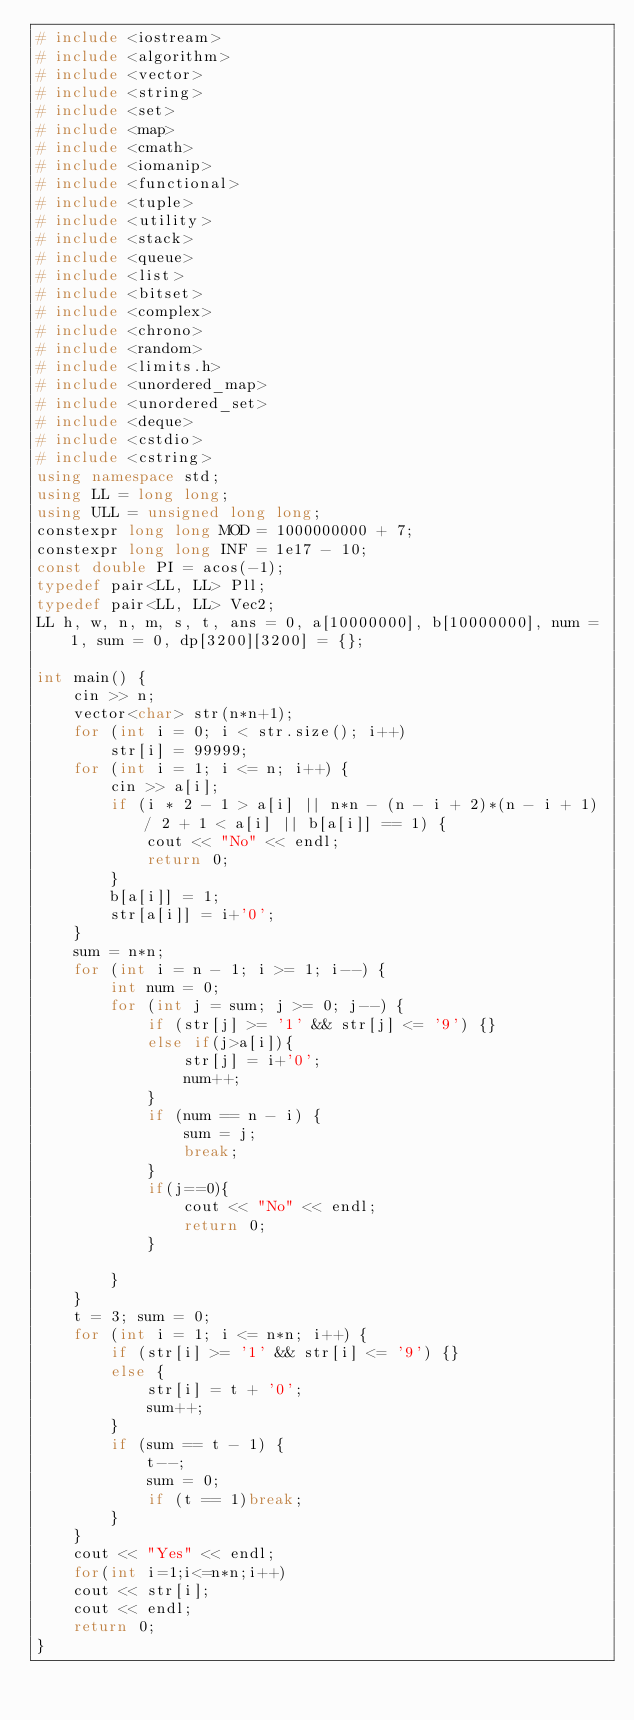<code> <loc_0><loc_0><loc_500><loc_500><_C++_># include <iostream>
# include <algorithm>
# include <vector>
# include <string>
# include <set>
# include <map>
# include <cmath>
# include <iomanip>
# include <functional>
# include <tuple>
# include <utility>
# include <stack>
# include <queue>
# include <list>
# include <bitset>
# include <complex>
# include <chrono>
# include <random>
# include <limits.h>
# include <unordered_map>
# include <unordered_set>
# include <deque>
# include <cstdio>
# include <cstring>
using namespace std;
using LL = long long;
using ULL = unsigned long long;
constexpr long long MOD = 1000000000 + 7;
constexpr long long INF = 1e17 - 10;
const double PI = acos(-1);
typedef pair<LL, LL> Pll;
typedef pair<LL, LL> Vec2;
LL h, w, n, m, s, t, ans = 0, a[10000000], b[10000000], num = 1, sum = 0, dp[3200][3200] = {};

int main() {
	cin >> n;
	vector<char> str(n*n+1);
	for (int i = 0; i < str.size(); i++)
		str[i] = 99999;
	for (int i = 1; i <= n; i++) {
		cin >> a[i];
		if (i * 2 - 1 > a[i] || n*n - (n - i + 2)*(n - i + 1) / 2 + 1 < a[i] || b[a[i]] == 1) {
			cout << "No" << endl;
			return 0;
		}
		b[a[i]] = 1;
		str[a[i]] = i+'0';
	}
	sum = n*n;
	for (int i = n - 1; i >= 1; i--) {
		int num = 0;
		for (int j = sum; j >= 0; j--) {
			if (str[j] >= '1' && str[j] <= '9') {}
			else if(j>a[i]){
				str[j] = i+'0';
				num++;
			}
			if (num == n - i) {
				sum = j;
				break;
			}
			if(j==0){
				cout << "No" << endl;
				return 0;
			}

		}
	}
	t = 3; sum = 0;
	for (int i = 1; i <= n*n; i++) {
		if (str[i] >= '1' && str[i] <= '9') {}
		else {
			str[i] = t + '0';
			sum++;
		}
		if (sum == t - 1) {
			t--;
			sum = 0;
			if (t == 1)break;
		}
	}
	cout << "Yes" << endl;
	for(int i=1;i<=n*n;i++)
	cout << str[i];
	cout << endl;
	return 0;
}</code> 